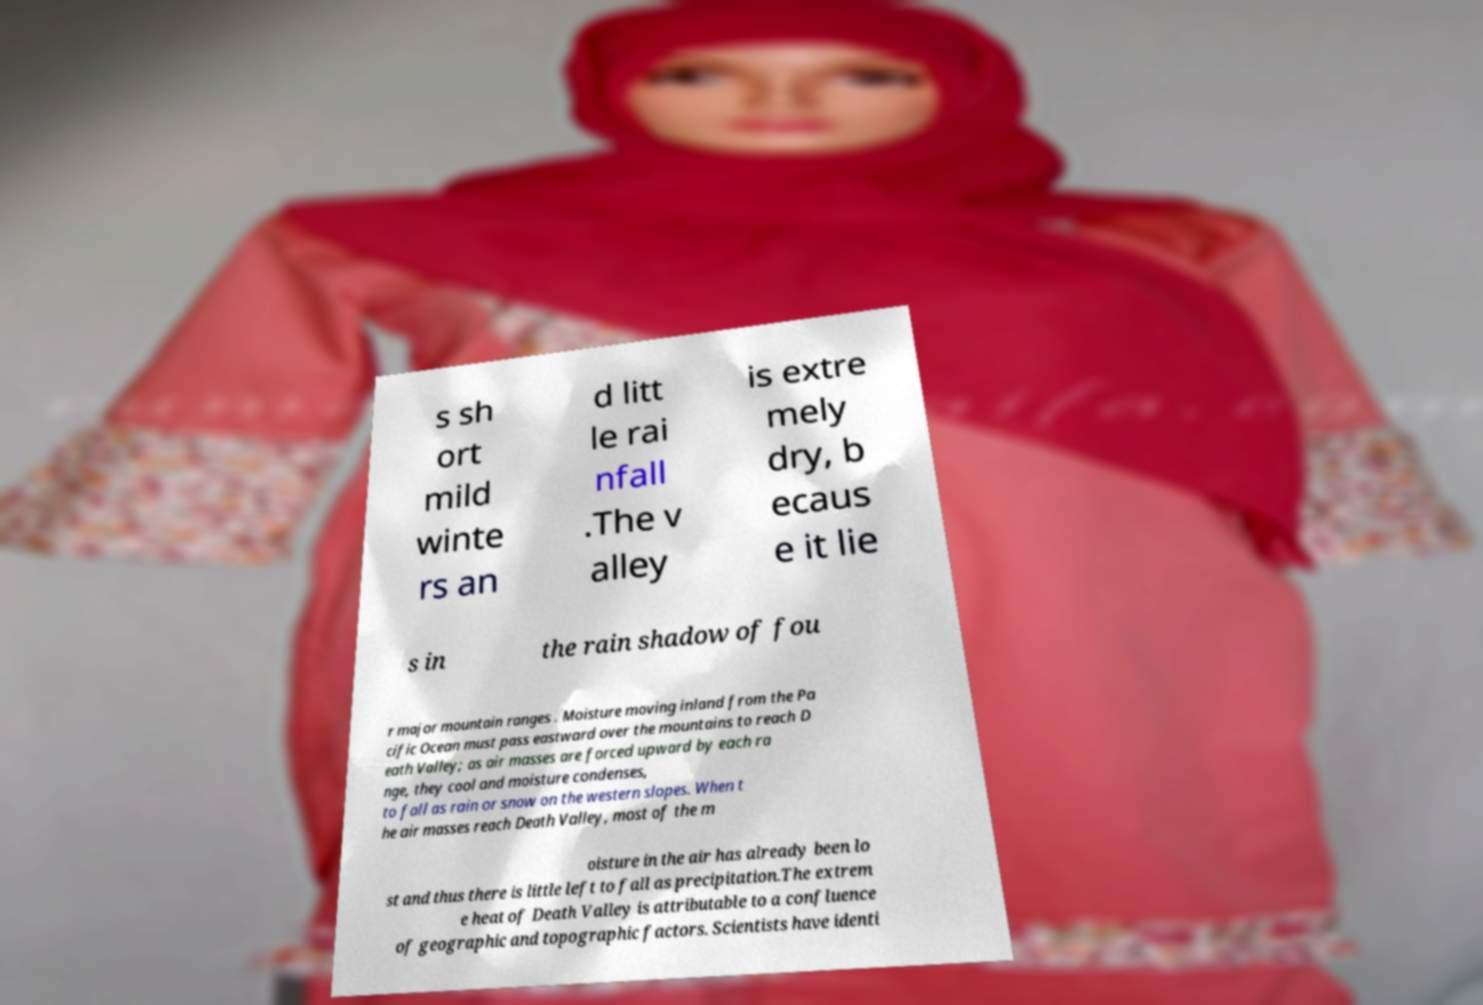There's text embedded in this image that I need extracted. Can you transcribe it verbatim? s sh ort mild winte rs an d litt le rai nfall .The v alley is extre mely dry, b ecaus e it lie s in the rain shadow of fou r major mountain ranges . Moisture moving inland from the Pa cific Ocean must pass eastward over the mountains to reach D eath Valley; as air masses are forced upward by each ra nge, they cool and moisture condenses, to fall as rain or snow on the western slopes. When t he air masses reach Death Valley, most of the m oisture in the air has already been lo st and thus there is little left to fall as precipitation.The extrem e heat of Death Valley is attributable to a confluence of geographic and topographic factors. Scientists have identi 